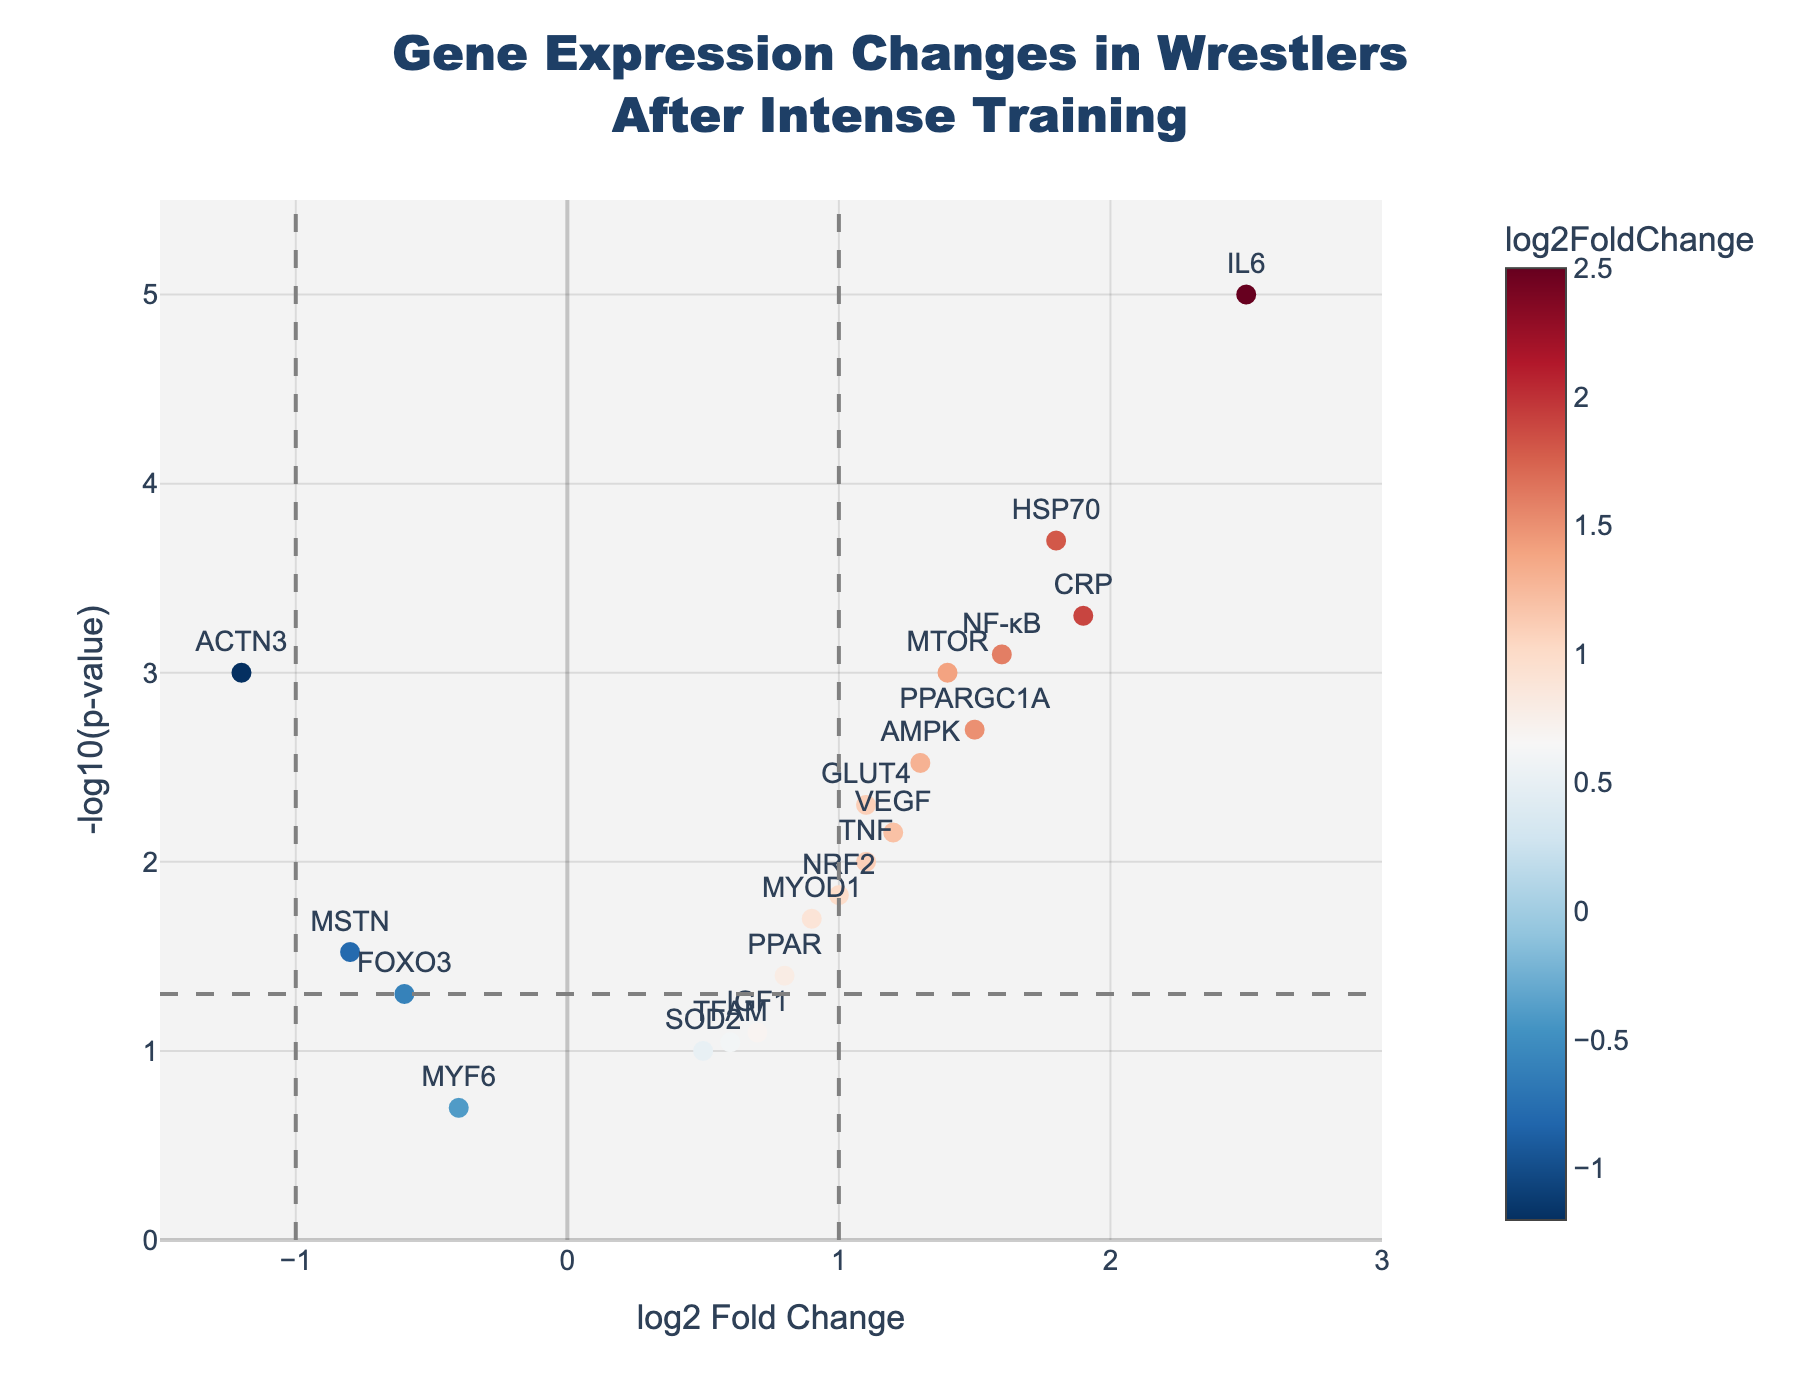Which gene has the highest -log10(p-value)? Look for the gene point with the highest position on the y-axis.
Answer: IL6 What is the log2 fold change for the gene MYOD1? Locate MYOD1 on the plot and check its horizontal position on the x-axis.
Answer: 0.9 How many genes have a significant p-value less than 0.05? Identify points above the dashed horizontal line that represents -log10(0.05). Count them.
Answer: 14 Which gene shows the greatest upregulation after training? The gene with the highest positive log2 fold change on the x-axis represents the greatest upregulation.
Answer: IL6 What is the log2 fold change threshold for significant regulation? Refer to the vertical dashed lines on either side of 0 on the x-axis.
Answer: ±1 Which gene has a log2 fold change lesser than -1 and a significant p-value? Find gene points to the left of the dashed vertical line at -1 and above the dashed horizontal line.
Answer: ACTN3 What is the relationship between fold change and p-value for gene TNF? Locate TNF and determine its x-axis (log2 fold change) and y-axis (-log10(p-value)) values.
Answer: log2FC: 1.1, -log10(p-value): 2 How many genes are downregulated (log2 fold change < 0) and have a significant p-value (< 0.05)? Count the data points left of 0 on the x-axis above the dashed horizontal line.
Answer: 3 Compare the -log10(p-value) of IL6 and CRP. Check the y-axis positions of IL6 and CRP and compare.
Answer: IL6 > CRP Which genes are located in the bottom-right quadrant of the plot? Identify genes with a log2 fold change > 0 and -log10(p-value) < -log10(0.05) (below the dashed horizontal line).
Answer: None 